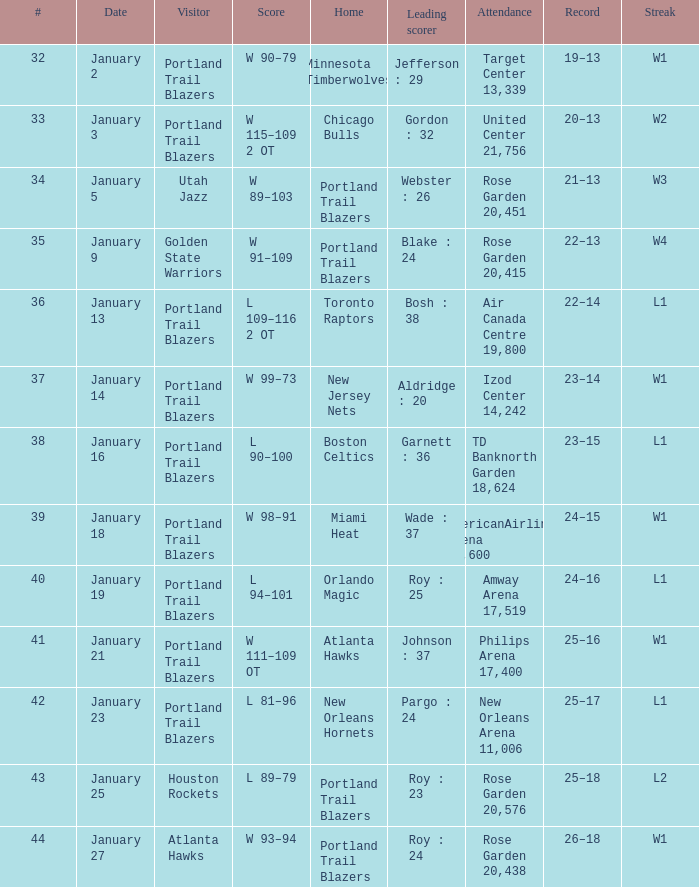Can you parse all the data within this table? {'header': ['#', 'Date', 'Visitor', 'Score', 'Home', 'Leading scorer', 'Attendance', 'Record', 'Streak'], 'rows': [['32', 'January 2', 'Portland Trail Blazers', 'W 90–79', 'Minnesota Timberwolves', 'Jefferson : 29', 'Target Center 13,339', '19–13', 'W1'], ['33', 'January 3', 'Portland Trail Blazers', 'W 115–109 2 OT', 'Chicago Bulls', 'Gordon : 32', 'United Center 21,756', '20–13', 'W2'], ['34', 'January 5', 'Utah Jazz', 'W 89–103', 'Portland Trail Blazers', 'Webster : 26', 'Rose Garden 20,451', '21–13', 'W3'], ['35', 'January 9', 'Golden State Warriors', 'W 91–109', 'Portland Trail Blazers', 'Blake : 24', 'Rose Garden 20,415', '22–13', 'W4'], ['36', 'January 13', 'Portland Trail Blazers', 'L 109–116 2 OT', 'Toronto Raptors', 'Bosh : 38', 'Air Canada Centre 19,800', '22–14', 'L1'], ['37', 'January 14', 'Portland Trail Blazers', 'W 99–73', 'New Jersey Nets', 'Aldridge : 20', 'Izod Center 14,242', '23–14', 'W1'], ['38', 'January 16', 'Portland Trail Blazers', 'L 90–100', 'Boston Celtics', 'Garnett : 36', 'TD Banknorth Garden 18,624', '23–15', 'L1'], ['39', 'January 18', 'Portland Trail Blazers', 'W 98–91', 'Miami Heat', 'Wade : 37', 'AmericanAirlines Arena 19,600', '24–15', 'W1'], ['40', 'January 19', 'Portland Trail Blazers', 'L 94–101', 'Orlando Magic', 'Roy : 25', 'Amway Arena 17,519', '24–16', 'L1'], ['41', 'January 21', 'Portland Trail Blazers', 'W 111–109 OT', 'Atlanta Hawks', 'Johnson : 37', 'Philips Arena 17,400', '25–16', 'W1'], ['42', 'January 23', 'Portland Trail Blazers', 'L 81–96', 'New Orleans Hornets', 'Pargo : 24', 'New Orleans Arena 11,006', '25–17', 'L1'], ['43', 'January 25', 'Houston Rockets', 'L 89–79', 'Portland Trail Blazers', 'Roy : 23', 'Rose Garden 20,576', '25–18', 'L2'], ['44', 'January 27', 'Atlanta Hawks', 'W 93–94', 'Portland Trail Blazers', 'Roy : 24', 'Rose Garden 20,438', '26–18', 'W1']]} What is the total number of dates where the scorer is gordon : 32 1.0. 